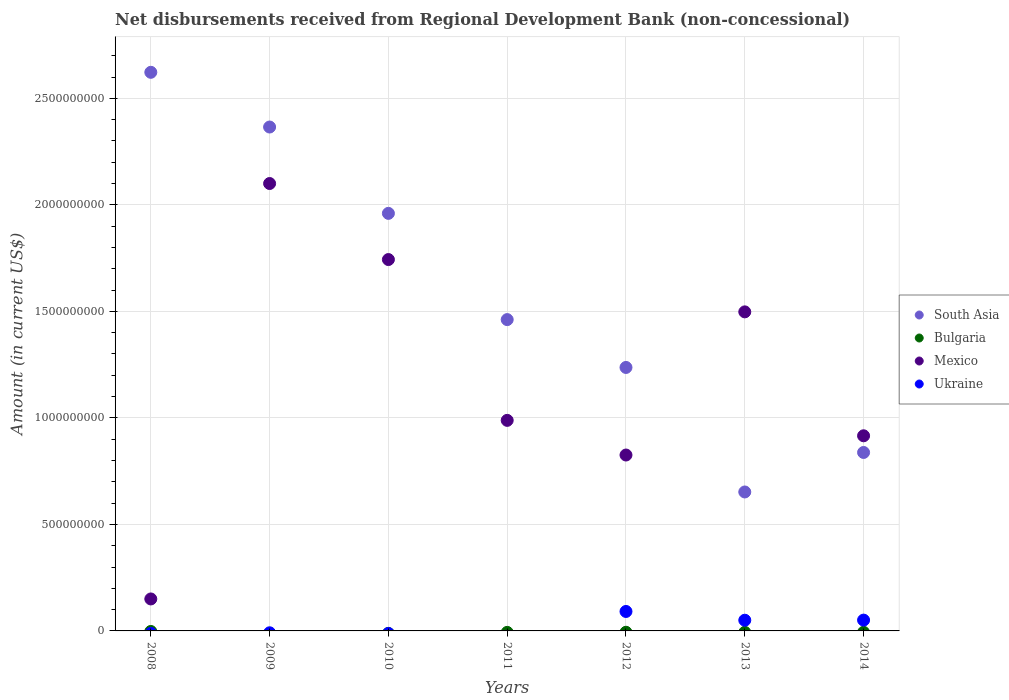How many different coloured dotlines are there?
Provide a succinct answer. 3. What is the amount of disbursements received from Regional Development Bank in South Asia in 2012?
Offer a terse response. 1.24e+09. Across all years, what is the maximum amount of disbursements received from Regional Development Bank in Mexico?
Provide a short and direct response. 2.10e+09. Across all years, what is the minimum amount of disbursements received from Regional Development Bank in Bulgaria?
Provide a short and direct response. 0. What is the difference between the amount of disbursements received from Regional Development Bank in South Asia in 2010 and that in 2014?
Keep it short and to the point. 1.12e+09. What is the difference between the amount of disbursements received from Regional Development Bank in Bulgaria in 2014 and the amount of disbursements received from Regional Development Bank in Mexico in 2008?
Your response must be concise. -1.50e+08. What is the average amount of disbursements received from Regional Development Bank in Ukraine per year?
Provide a succinct answer. 2.75e+07. In the year 2013, what is the difference between the amount of disbursements received from Regional Development Bank in Mexico and amount of disbursements received from Regional Development Bank in Ukraine?
Make the answer very short. 1.45e+09. What is the ratio of the amount of disbursements received from Regional Development Bank in South Asia in 2009 to that in 2011?
Ensure brevity in your answer.  1.62. What is the difference between the highest and the second highest amount of disbursements received from Regional Development Bank in South Asia?
Provide a short and direct response. 2.57e+08. What is the difference between the highest and the lowest amount of disbursements received from Regional Development Bank in Ukraine?
Keep it short and to the point. 9.13e+07. Is the sum of the amount of disbursements received from Regional Development Bank in Mexico in 2010 and 2013 greater than the maximum amount of disbursements received from Regional Development Bank in Ukraine across all years?
Ensure brevity in your answer.  Yes. Is it the case that in every year, the sum of the amount of disbursements received from Regional Development Bank in Mexico and amount of disbursements received from Regional Development Bank in Ukraine  is greater than the sum of amount of disbursements received from Regional Development Bank in Bulgaria and amount of disbursements received from Regional Development Bank in South Asia?
Give a very brief answer. Yes. Does the amount of disbursements received from Regional Development Bank in Ukraine monotonically increase over the years?
Provide a succinct answer. No. Is the amount of disbursements received from Regional Development Bank in South Asia strictly greater than the amount of disbursements received from Regional Development Bank in Ukraine over the years?
Offer a very short reply. Yes. How many dotlines are there?
Keep it short and to the point. 3. Does the graph contain any zero values?
Give a very brief answer. Yes. Does the graph contain grids?
Keep it short and to the point. Yes. Where does the legend appear in the graph?
Give a very brief answer. Center right. How are the legend labels stacked?
Ensure brevity in your answer.  Vertical. What is the title of the graph?
Your answer should be compact. Net disbursements received from Regional Development Bank (non-concessional). What is the label or title of the X-axis?
Your answer should be compact. Years. What is the label or title of the Y-axis?
Keep it short and to the point. Amount (in current US$). What is the Amount (in current US$) in South Asia in 2008?
Ensure brevity in your answer.  2.62e+09. What is the Amount (in current US$) in Mexico in 2008?
Make the answer very short. 1.50e+08. What is the Amount (in current US$) of South Asia in 2009?
Make the answer very short. 2.37e+09. What is the Amount (in current US$) in Bulgaria in 2009?
Keep it short and to the point. 0. What is the Amount (in current US$) in Mexico in 2009?
Offer a very short reply. 2.10e+09. What is the Amount (in current US$) in Ukraine in 2009?
Your answer should be very brief. 0. What is the Amount (in current US$) in South Asia in 2010?
Provide a short and direct response. 1.96e+09. What is the Amount (in current US$) in Mexico in 2010?
Make the answer very short. 1.74e+09. What is the Amount (in current US$) in South Asia in 2011?
Make the answer very short. 1.46e+09. What is the Amount (in current US$) of Mexico in 2011?
Make the answer very short. 9.88e+08. What is the Amount (in current US$) in Ukraine in 2011?
Offer a terse response. 0. What is the Amount (in current US$) of South Asia in 2012?
Your answer should be very brief. 1.24e+09. What is the Amount (in current US$) in Mexico in 2012?
Your answer should be compact. 8.26e+08. What is the Amount (in current US$) of Ukraine in 2012?
Your answer should be compact. 9.13e+07. What is the Amount (in current US$) in South Asia in 2013?
Make the answer very short. 6.52e+08. What is the Amount (in current US$) in Mexico in 2013?
Offer a very short reply. 1.50e+09. What is the Amount (in current US$) in Ukraine in 2013?
Provide a succinct answer. 5.02e+07. What is the Amount (in current US$) of South Asia in 2014?
Offer a very short reply. 8.38e+08. What is the Amount (in current US$) in Bulgaria in 2014?
Keep it short and to the point. 0. What is the Amount (in current US$) of Mexico in 2014?
Offer a terse response. 9.16e+08. What is the Amount (in current US$) of Ukraine in 2014?
Provide a short and direct response. 5.08e+07. Across all years, what is the maximum Amount (in current US$) of South Asia?
Keep it short and to the point. 2.62e+09. Across all years, what is the maximum Amount (in current US$) in Mexico?
Make the answer very short. 2.10e+09. Across all years, what is the maximum Amount (in current US$) of Ukraine?
Your answer should be compact. 9.13e+07. Across all years, what is the minimum Amount (in current US$) in South Asia?
Offer a terse response. 6.52e+08. Across all years, what is the minimum Amount (in current US$) of Mexico?
Your response must be concise. 1.50e+08. Across all years, what is the minimum Amount (in current US$) of Ukraine?
Provide a short and direct response. 0. What is the total Amount (in current US$) in South Asia in the graph?
Ensure brevity in your answer.  1.11e+1. What is the total Amount (in current US$) in Mexico in the graph?
Offer a terse response. 8.22e+09. What is the total Amount (in current US$) of Ukraine in the graph?
Give a very brief answer. 1.92e+08. What is the difference between the Amount (in current US$) in South Asia in 2008 and that in 2009?
Offer a terse response. 2.57e+08. What is the difference between the Amount (in current US$) in Mexico in 2008 and that in 2009?
Offer a very short reply. -1.95e+09. What is the difference between the Amount (in current US$) in South Asia in 2008 and that in 2010?
Your response must be concise. 6.62e+08. What is the difference between the Amount (in current US$) in Mexico in 2008 and that in 2010?
Provide a succinct answer. -1.59e+09. What is the difference between the Amount (in current US$) of South Asia in 2008 and that in 2011?
Make the answer very short. 1.16e+09. What is the difference between the Amount (in current US$) in Mexico in 2008 and that in 2011?
Give a very brief answer. -8.38e+08. What is the difference between the Amount (in current US$) in South Asia in 2008 and that in 2012?
Make the answer very short. 1.39e+09. What is the difference between the Amount (in current US$) of Mexico in 2008 and that in 2012?
Your response must be concise. -6.76e+08. What is the difference between the Amount (in current US$) of South Asia in 2008 and that in 2013?
Keep it short and to the point. 1.97e+09. What is the difference between the Amount (in current US$) in Mexico in 2008 and that in 2013?
Provide a short and direct response. -1.35e+09. What is the difference between the Amount (in current US$) of South Asia in 2008 and that in 2014?
Your answer should be compact. 1.78e+09. What is the difference between the Amount (in current US$) of Mexico in 2008 and that in 2014?
Ensure brevity in your answer.  -7.66e+08. What is the difference between the Amount (in current US$) in South Asia in 2009 and that in 2010?
Provide a succinct answer. 4.05e+08. What is the difference between the Amount (in current US$) in Mexico in 2009 and that in 2010?
Keep it short and to the point. 3.57e+08. What is the difference between the Amount (in current US$) of South Asia in 2009 and that in 2011?
Offer a very short reply. 9.04e+08. What is the difference between the Amount (in current US$) in Mexico in 2009 and that in 2011?
Your answer should be very brief. 1.11e+09. What is the difference between the Amount (in current US$) of South Asia in 2009 and that in 2012?
Ensure brevity in your answer.  1.13e+09. What is the difference between the Amount (in current US$) of Mexico in 2009 and that in 2012?
Offer a very short reply. 1.27e+09. What is the difference between the Amount (in current US$) of South Asia in 2009 and that in 2013?
Offer a terse response. 1.71e+09. What is the difference between the Amount (in current US$) in Mexico in 2009 and that in 2013?
Your answer should be very brief. 6.03e+08. What is the difference between the Amount (in current US$) of South Asia in 2009 and that in 2014?
Ensure brevity in your answer.  1.53e+09. What is the difference between the Amount (in current US$) of Mexico in 2009 and that in 2014?
Provide a succinct answer. 1.18e+09. What is the difference between the Amount (in current US$) of South Asia in 2010 and that in 2011?
Offer a very short reply. 4.99e+08. What is the difference between the Amount (in current US$) of Mexico in 2010 and that in 2011?
Your answer should be very brief. 7.55e+08. What is the difference between the Amount (in current US$) in South Asia in 2010 and that in 2012?
Your answer should be compact. 7.23e+08. What is the difference between the Amount (in current US$) of Mexico in 2010 and that in 2012?
Provide a short and direct response. 9.18e+08. What is the difference between the Amount (in current US$) of South Asia in 2010 and that in 2013?
Keep it short and to the point. 1.31e+09. What is the difference between the Amount (in current US$) in Mexico in 2010 and that in 2013?
Offer a very short reply. 2.46e+08. What is the difference between the Amount (in current US$) in South Asia in 2010 and that in 2014?
Provide a succinct answer. 1.12e+09. What is the difference between the Amount (in current US$) of Mexico in 2010 and that in 2014?
Ensure brevity in your answer.  8.27e+08. What is the difference between the Amount (in current US$) in South Asia in 2011 and that in 2012?
Your answer should be compact. 2.25e+08. What is the difference between the Amount (in current US$) in Mexico in 2011 and that in 2012?
Your answer should be compact. 1.63e+08. What is the difference between the Amount (in current US$) of South Asia in 2011 and that in 2013?
Provide a short and direct response. 8.09e+08. What is the difference between the Amount (in current US$) in Mexico in 2011 and that in 2013?
Ensure brevity in your answer.  -5.09e+08. What is the difference between the Amount (in current US$) in South Asia in 2011 and that in 2014?
Offer a terse response. 6.24e+08. What is the difference between the Amount (in current US$) in Mexico in 2011 and that in 2014?
Offer a terse response. 7.24e+07. What is the difference between the Amount (in current US$) in South Asia in 2012 and that in 2013?
Your answer should be very brief. 5.85e+08. What is the difference between the Amount (in current US$) of Mexico in 2012 and that in 2013?
Your answer should be very brief. -6.72e+08. What is the difference between the Amount (in current US$) in Ukraine in 2012 and that in 2013?
Offer a terse response. 4.11e+07. What is the difference between the Amount (in current US$) in South Asia in 2012 and that in 2014?
Provide a succinct answer. 3.99e+08. What is the difference between the Amount (in current US$) in Mexico in 2012 and that in 2014?
Offer a very short reply. -9.03e+07. What is the difference between the Amount (in current US$) of Ukraine in 2012 and that in 2014?
Your answer should be very brief. 4.06e+07. What is the difference between the Amount (in current US$) of South Asia in 2013 and that in 2014?
Your response must be concise. -1.85e+08. What is the difference between the Amount (in current US$) in Mexico in 2013 and that in 2014?
Your answer should be very brief. 5.82e+08. What is the difference between the Amount (in current US$) in Ukraine in 2013 and that in 2014?
Ensure brevity in your answer.  -5.47e+05. What is the difference between the Amount (in current US$) of South Asia in 2008 and the Amount (in current US$) of Mexico in 2009?
Your answer should be compact. 5.22e+08. What is the difference between the Amount (in current US$) of South Asia in 2008 and the Amount (in current US$) of Mexico in 2010?
Ensure brevity in your answer.  8.79e+08. What is the difference between the Amount (in current US$) of South Asia in 2008 and the Amount (in current US$) of Mexico in 2011?
Ensure brevity in your answer.  1.63e+09. What is the difference between the Amount (in current US$) of South Asia in 2008 and the Amount (in current US$) of Mexico in 2012?
Ensure brevity in your answer.  1.80e+09. What is the difference between the Amount (in current US$) of South Asia in 2008 and the Amount (in current US$) of Ukraine in 2012?
Keep it short and to the point. 2.53e+09. What is the difference between the Amount (in current US$) in Mexico in 2008 and the Amount (in current US$) in Ukraine in 2012?
Offer a terse response. 5.87e+07. What is the difference between the Amount (in current US$) in South Asia in 2008 and the Amount (in current US$) in Mexico in 2013?
Ensure brevity in your answer.  1.12e+09. What is the difference between the Amount (in current US$) in South Asia in 2008 and the Amount (in current US$) in Ukraine in 2013?
Your answer should be very brief. 2.57e+09. What is the difference between the Amount (in current US$) in Mexico in 2008 and the Amount (in current US$) in Ukraine in 2013?
Give a very brief answer. 9.99e+07. What is the difference between the Amount (in current US$) in South Asia in 2008 and the Amount (in current US$) in Mexico in 2014?
Give a very brief answer. 1.71e+09. What is the difference between the Amount (in current US$) in South Asia in 2008 and the Amount (in current US$) in Ukraine in 2014?
Provide a succinct answer. 2.57e+09. What is the difference between the Amount (in current US$) in Mexico in 2008 and the Amount (in current US$) in Ukraine in 2014?
Your answer should be compact. 9.93e+07. What is the difference between the Amount (in current US$) of South Asia in 2009 and the Amount (in current US$) of Mexico in 2010?
Make the answer very short. 6.22e+08. What is the difference between the Amount (in current US$) of South Asia in 2009 and the Amount (in current US$) of Mexico in 2011?
Keep it short and to the point. 1.38e+09. What is the difference between the Amount (in current US$) in South Asia in 2009 and the Amount (in current US$) in Mexico in 2012?
Your response must be concise. 1.54e+09. What is the difference between the Amount (in current US$) of South Asia in 2009 and the Amount (in current US$) of Ukraine in 2012?
Give a very brief answer. 2.27e+09. What is the difference between the Amount (in current US$) of Mexico in 2009 and the Amount (in current US$) of Ukraine in 2012?
Provide a short and direct response. 2.01e+09. What is the difference between the Amount (in current US$) of South Asia in 2009 and the Amount (in current US$) of Mexico in 2013?
Give a very brief answer. 8.68e+08. What is the difference between the Amount (in current US$) in South Asia in 2009 and the Amount (in current US$) in Ukraine in 2013?
Offer a very short reply. 2.32e+09. What is the difference between the Amount (in current US$) of Mexico in 2009 and the Amount (in current US$) of Ukraine in 2013?
Make the answer very short. 2.05e+09. What is the difference between the Amount (in current US$) of South Asia in 2009 and the Amount (in current US$) of Mexico in 2014?
Make the answer very short. 1.45e+09. What is the difference between the Amount (in current US$) of South Asia in 2009 and the Amount (in current US$) of Ukraine in 2014?
Offer a very short reply. 2.31e+09. What is the difference between the Amount (in current US$) in Mexico in 2009 and the Amount (in current US$) in Ukraine in 2014?
Give a very brief answer. 2.05e+09. What is the difference between the Amount (in current US$) in South Asia in 2010 and the Amount (in current US$) in Mexico in 2011?
Give a very brief answer. 9.72e+08. What is the difference between the Amount (in current US$) in South Asia in 2010 and the Amount (in current US$) in Mexico in 2012?
Give a very brief answer. 1.13e+09. What is the difference between the Amount (in current US$) in South Asia in 2010 and the Amount (in current US$) in Ukraine in 2012?
Offer a very short reply. 1.87e+09. What is the difference between the Amount (in current US$) of Mexico in 2010 and the Amount (in current US$) of Ukraine in 2012?
Your answer should be very brief. 1.65e+09. What is the difference between the Amount (in current US$) of South Asia in 2010 and the Amount (in current US$) of Mexico in 2013?
Your answer should be very brief. 4.62e+08. What is the difference between the Amount (in current US$) in South Asia in 2010 and the Amount (in current US$) in Ukraine in 2013?
Make the answer very short. 1.91e+09. What is the difference between the Amount (in current US$) of Mexico in 2010 and the Amount (in current US$) of Ukraine in 2013?
Ensure brevity in your answer.  1.69e+09. What is the difference between the Amount (in current US$) of South Asia in 2010 and the Amount (in current US$) of Mexico in 2014?
Make the answer very short. 1.04e+09. What is the difference between the Amount (in current US$) of South Asia in 2010 and the Amount (in current US$) of Ukraine in 2014?
Ensure brevity in your answer.  1.91e+09. What is the difference between the Amount (in current US$) of Mexico in 2010 and the Amount (in current US$) of Ukraine in 2014?
Offer a terse response. 1.69e+09. What is the difference between the Amount (in current US$) in South Asia in 2011 and the Amount (in current US$) in Mexico in 2012?
Make the answer very short. 6.36e+08. What is the difference between the Amount (in current US$) of South Asia in 2011 and the Amount (in current US$) of Ukraine in 2012?
Your answer should be very brief. 1.37e+09. What is the difference between the Amount (in current US$) of Mexico in 2011 and the Amount (in current US$) of Ukraine in 2012?
Provide a short and direct response. 8.97e+08. What is the difference between the Amount (in current US$) in South Asia in 2011 and the Amount (in current US$) in Mexico in 2013?
Provide a short and direct response. -3.63e+07. What is the difference between the Amount (in current US$) in South Asia in 2011 and the Amount (in current US$) in Ukraine in 2013?
Provide a succinct answer. 1.41e+09. What is the difference between the Amount (in current US$) in Mexico in 2011 and the Amount (in current US$) in Ukraine in 2013?
Your answer should be very brief. 9.38e+08. What is the difference between the Amount (in current US$) of South Asia in 2011 and the Amount (in current US$) of Mexico in 2014?
Your answer should be very brief. 5.45e+08. What is the difference between the Amount (in current US$) of South Asia in 2011 and the Amount (in current US$) of Ukraine in 2014?
Provide a succinct answer. 1.41e+09. What is the difference between the Amount (in current US$) of Mexico in 2011 and the Amount (in current US$) of Ukraine in 2014?
Keep it short and to the point. 9.38e+08. What is the difference between the Amount (in current US$) in South Asia in 2012 and the Amount (in current US$) in Mexico in 2013?
Your answer should be very brief. -2.61e+08. What is the difference between the Amount (in current US$) of South Asia in 2012 and the Amount (in current US$) of Ukraine in 2013?
Your response must be concise. 1.19e+09. What is the difference between the Amount (in current US$) in Mexico in 2012 and the Amount (in current US$) in Ukraine in 2013?
Keep it short and to the point. 7.75e+08. What is the difference between the Amount (in current US$) of South Asia in 2012 and the Amount (in current US$) of Mexico in 2014?
Provide a short and direct response. 3.21e+08. What is the difference between the Amount (in current US$) of South Asia in 2012 and the Amount (in current US$) of Ukraine in 2014?
Provide a succinct answer. 1.19e+09. What is the difference between the Amount (in current US$) in Mexico in 2012 and the Amount (in current US$) in Ukraine in 2014?
Your answer should be very brief. 7.75e+08. What is the difference between the Amount (in current US$) in South Asia in 2013 and the Amount (in current US$) in Mexico in 2014?
Your response must be concise. -2.64e+08. What is the difference between the Amount (in current US$) of South Asia in 2013 and the Amount (in current US$) of Ukraine in 2014?
Your answer should be compact. 6.02e+08. What is the difference between the Amount (in current US$) of Mexico in 2013 and the Amount (in current US$) of Ukraine in 2014?
Ensure brevity in your answer.  1.45e+09. What is the average Amount (in current US$) in South Asia per year?
Ensure brevity in your answer.  1.59e+09. What is the average Amount (in current US$) in Bulgaria per year?
Your response must be concise. 0. What is the average Amount (in current US$) in Mexico per year?
Make the answer very short. 1.17e+09. What is the average Amount (in current US$) of Ukraine per year?
Keep it short and to the point. 2.75e+07. In the year 2008, what is the difference between the Amount (in current US$) in South Asia and Amount (in current US$) in Mexico?
Ensure brevity in your answer.  2.47e+09. In the year 2009, what is the difference between the Amount (in current US$) in South Asia and Amount (in current US$) in Mexico?
Your answer should be very brief. 2.65e+08. In the year 2010, what is the difference between the Amount (in current US$) of South Asia and Amount (in current US$) of Mexico?
Keep it short and to the point. 2.17e+08. In the year 2011, what is the difference between the Amount (in current US$) of South Asia and Amount (in current US$) of Mexico?
Provide a succinct answer. 4.73e+08. In the year 2012, what is the difference between the Amount (in current US$) in South Asia and Amount (in current US$) in Mexico?
Provide a succinct answer. 4.11e+08. In the year 2012, what is the difference between the Amount (in current US$) of South Asia and Amount (in current US$) of Ukraine?
Offer a terse response. 1.15e+09. In the year 2012, what is the difference between the Amount (in current US$) of Mexico and Amount (in current US$) of Ukraine?
Your response must be concise. 7.34e+08. In the year 2013, what is the difference between the Amount (in current US$) of South Asia and Amount (in current US$) of Mexico?
Offer a terse response. -8.45e+08. In the year 2013, what is the difference between the Amount (in current US$) of South Asia and Amount (in current US$) of Ukraine?
Give a very brief answer. 6.02e+08. In the year 2013, what is the difference between the Amount (in current US$) in Mexico and Amount (in current US$) in Ukraine?
Give a very brief answer. 1.45e+09. In the year 2014, what is the difference between the Amount (in current US$) of South Asia and Amount (in current US$) of Mexico?
Offer a very short reply. -7.83e+07. In the year 2014, what is the difference between the Amount (in current US$) of South Asia and Amount (in current US$) of Ukraine?
Give a very brief answer. 7.87e+08. In the year 2014, what is the difference between the Amount (in current US$) in Mexico and Amount (in current US$) in Ukraine?
Your response must be concise. 8.65e+08. What is the ratio of the Amount (in current US$) in South Asia in 2008 to that in 2009?
Your answer should be very brief. 1.11. What is the ratio of the Amount (in current US$) in Mexico in 2008 to that in 2009?
Keep it short and to the point. 0.07. What is the ratio of the Amount (in current US$) of South Asia in 2008 to that in 2010?
Offer a very short reply. 1.34. What is the ratio of the Amount (in current US$) of Mexico in 2008 to that in 2010?
Give a very brief answer. 0.09. What is the ratio of the Amount (in current US$) of South Asia in 2008 to that in 2011?
Your answer should be very brief. 1.79. What is the ratio of the Amount (in current US$) of Mexico in 2008 to that in 2011?
Give a very brief answer. 0.15. What is the ratio of the Amount (in current US$) of South Asia in 2008 to that in 2012?
Your answer should be very brief. 2.12. What is the ratio of the Amount (in current US$) in Mexico in 2008 to that in 2012?
Offer a terse response. 0.18. What is the ratio of the Amount (in current US$) in South Asia in 2008 to that in 2013?
Ensure brevity in your answer.  4.02. What is the ratio of the Amount (in current US$) in Mexico in 2008 to that in 2013?
Ensure brevity in your answer.  0.1. What is the ratio of the Amount (in current US$) in South Asia in 2008 to that in 2014?
Your response must be concise. 3.13. What is the ratio of the Amount (in current US$) of Mexico in 2008 to that in 2014?
Make the answer very short. 0.16. What is the ratio of the Amount (in current US$) in South Asia in 2009 to that in 2010?
Offer a very short reply. 1.21. What is the ratio of the Amount (in current US$) in Mexico in 2009 to that in 2010?
Keep it short and to the point. 1.2. What is the ratio of the Amount (in current US$) of South Asia in 2009 to that in 2011?
Offer a very short reply. 1.62. What is the ratio of the Amount (in current US$) of Mexico in 2009 to that in 2011?
Offer a very short reply. 2.12. What is the ratio of the Amount (in current US$) in South Asia in 2009 to that in 2012?
Offer a terse response. 1.91. What is the ratio of the Amount (in current US$) of Mexico in 2009 to that in 2012?
Keep it short and to the point. 2.54. What is the ratio of the Amount (in current US$) in South Asia in 2009 to that in 2013?
Provide a succinct answer. 3.63. What is the ratio of the Amount (in current US$) of Mexico in 2009 to that in 2013?
Keep it short and to the point. 1.4. What is the ratio of the Amount (in current US$) in South Asia in 2009 to that in 2014?
Keep it short and to the point. 2.82. What is the ratio of the Amount (in current US$) in Mexico in 2009 to that in 2014?
Ensure brevity in your answer.  2.29. What is the ratio of the Amount (in current US$) of South Asia in 2010 to that in 2011?
Make the answer very short. 1.34. What is the ratio of the Amount (in current US$) in Mexico in 2010 to that in 2011?
Provide a succinct answer. 1.76. What is the ratio of the Amount (in current US$) in South Asia in 2010 to that in 2012?
Keep it short and to the point. 1.58. What is the ratio of the Amount (in current US$) in Mexico in 2010 to that in 2012?
Make the answer very short. 2.11. What is the ratio of the Amount (in current US$) of South Asia in 2010 to that in 2013?
Your answer should be very brief. 3.01. What is the ratio of the Amount (in current US$) of Mexico in 2010 to that in 2013?
Keep it short and to the point. 1.16. What is the ratio of the Amount (in current US$) in South Asia in 2010 to that in 2014?
Make the answer very short. 2.34. What is the ratio of the Amount (in current US$) in Mexico in 2010 to that in 2014?
Keep it short and to the point. 1.9. What is the ratio of the Amount (in current US$) of South Asia in 2011 to that in 2012?
Keep it short and to the point. 1.18. What is the ratio of the Amount (in current US$) in Mexico in 2011 to that in 2012?
Offer a terse response. 1.2. What is the ratio of the Amount (in current US$) in South Asia in 2011 to that in 2013?
Offer a very short reply. 2.24. What is the ratio of the Amount (in current US$) of Mexico in 2011 to that in 2013?
Provide a short and direct response. 0.66. What is the ratio of the Amount (in current US$) of South Asia in 2011 to that in 2014?
Your response must be concise. 1.74. What is the ratio of the Amount (in current US$) of Mexico in 2011 to that in 2014?
Keep it short and to the point. 1.08. What is the ratio of the Amount (in current US$) in South Asia in 2012 to that in 2013?
Offer a terse response. 1.9. What is the ratio of the Amount (in current US$) of Mexico in 2012 to that in 2013?
Give a very brief answer. 0.55. What is the ratio of the Amount (in current US$) in Ukraine in 2012 to that in 2013?
Provide a short and direct response. 1.82. What is the ratio of the Amount (in current US$) of South Asia in 2012 to that in 2014?
Your response must be concise. 1.48. What is the ratio of the Amount (in current US$) of Mexico in 2012 to that in 2014?
Offer a terse response. 0.9. What is the ratio of the Amount (in current US$) of Ukraine in 2012 to that in 2014?
Provide a short and direct response. 1.8. What is the ratio of the Amount (in current US$) of South Asia in 2013 to that in 2014?
Ensure brevity in your answer.  0.78. What is the ratio of the Amount (in current US$) in Mexico in 2013 to that in 2014?
Your answer should be very brief. 1.64. What is the difference between the highest and the second highest Amount (in current US$) in South Asia?
Provide a succinct answer. 2.57e+08. What is the difference between the highest and the second highest Amount (in current US$) of Mexico?
Offer a very short reply. 3.57e+08. What is the difference between the highest and the second highest Amount (in current US$) in Ukraine?
Ensure brevity in your answer.  4.06e+07. What is the difference between the highest and the lowest Amount (in current US$) in South Asia?
Your answer should be compact. 1.97e+09. What is the difference between the highest and the lowest Amount (in current US$) of Mexico?
Ensure brevity in your answer.  1.95e+09. What is the difference between the highest and the lowest Amount (in current US$) of Ukraine?
Offer a very short reply. 9.13e+07. 